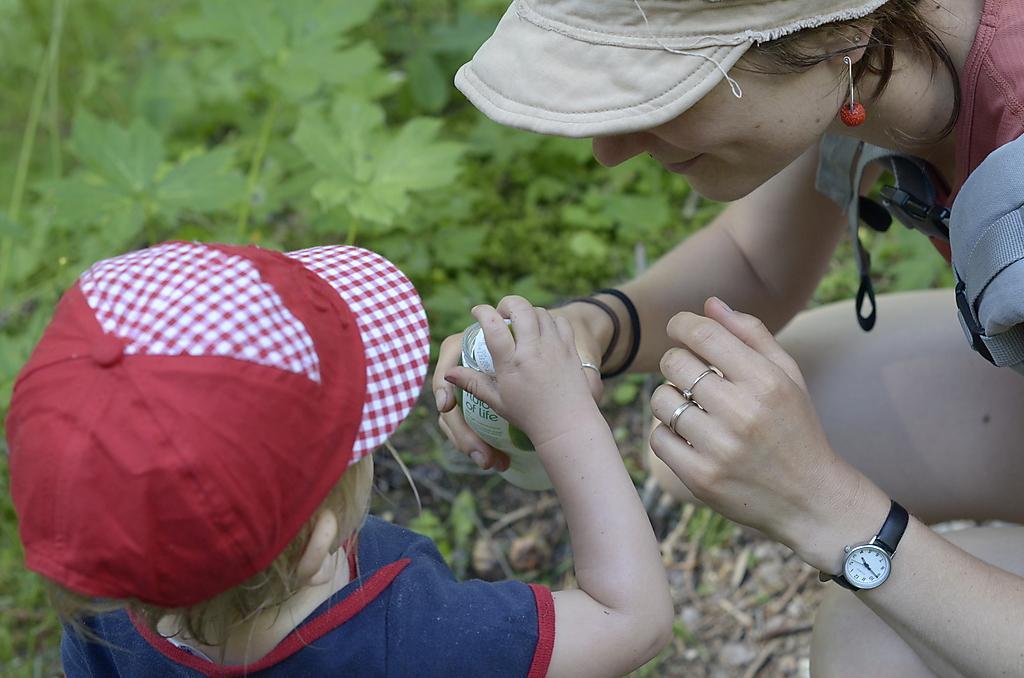Please provide a concise description of this image. In this image we can see a woman and baby. The woman is wearing brown color cap , red jacket and holding bottle in her hand. The child is wearing red color cap with blue t-shirt. Background of the image leaves and stems are present. 